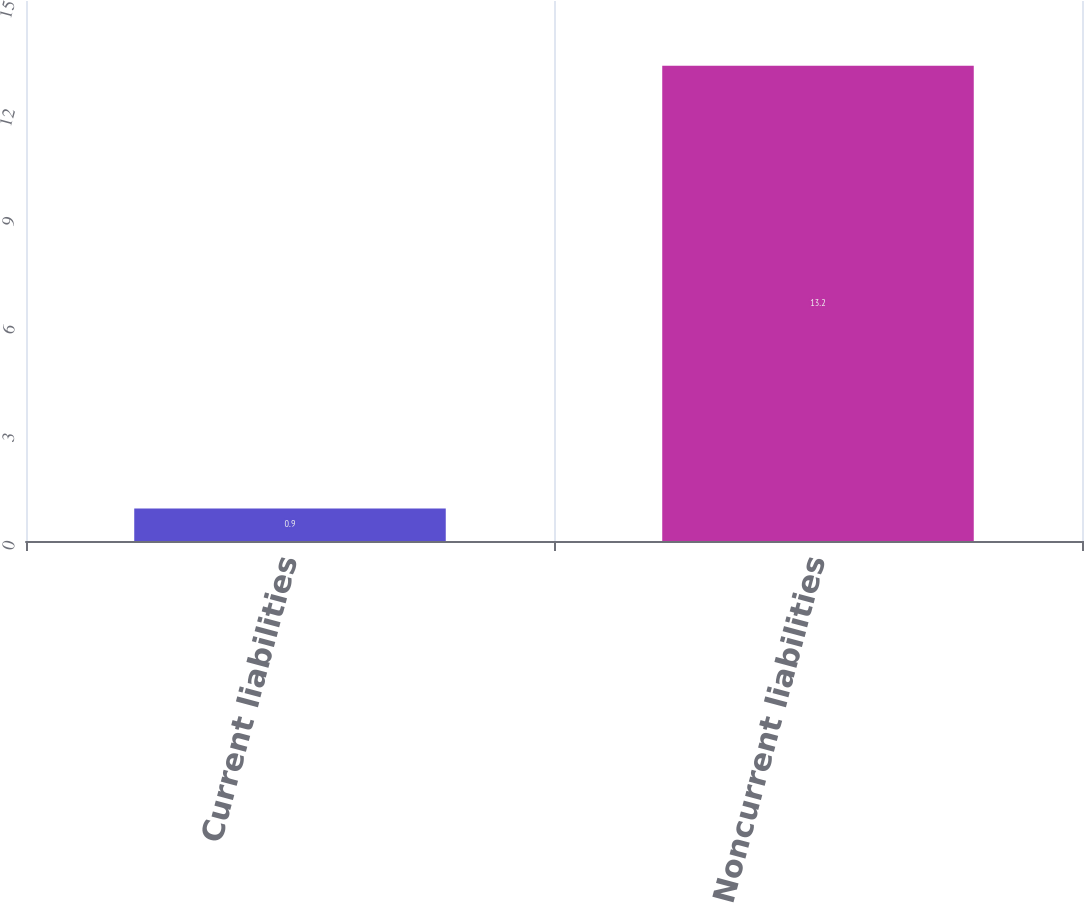Convert chart. <chart><loc_0><loc_0><loc_500><loc_500><bar_chart><fcel>Current liabilities<fcel>Noncurrent liabilities<nl><fcel>0.9<fcel>13.2<nl></chart> 